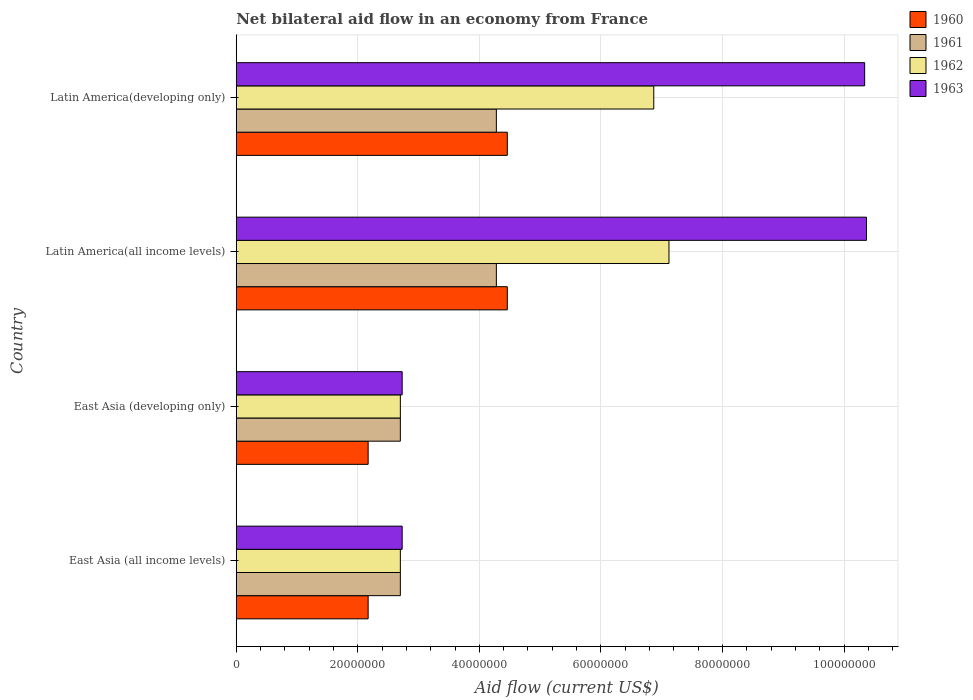How many different coloured bars are there?
Make the answer very short. 4. Are the number of bars per tick equal to the number of legend labels?
Offer a terse response. Yes. Are the number of bars on each tick of the Y-axis equal?
Your response must be concise. Yes. How many bars are there on the 1st tick from the top?
Ensure brevity in your answer.  4. How many bars are there on the 3rd tick from the bottom?
Provide a short and direct response. 4. What is the label of the 1st group of bars from the top?
Your response must be concise. Latin America(developing only). In how many cases, is the number of bars for a given country not equal to the number of legend labels?
Give a very brief answer. 0. What is the net bilateral aid flow in 1961 in East Asia (developing only)?
Offer a very short reply. 2.70e+07. Across all countries, what is the maximum net bilateral aid flow in 1960?
Keep it short and to the point. 4.46e+07. Across all countries, what is the minimum net bilateral aid flow in 1963?
Your answer should be compact. 2.73e+07. In which country was the net bilateral aid flow in 1962 maximum?
Give a very brief answer. Latin America(all income levels). In which country was the net bilateral aid flow in 1960 minimum?
Provide a short and direct response. East Asia (all income levels). What is the total net bilateral aid flow in 1963 in the graph?
Make the answer very short. 2.62e+08. What is the difference between the net bilateral aid flow in 1960 in Latin America(all income levels) and that in Latin America(developing only)?
Provide a succinct answer. 0. What is the difference between the net bilateral aid flow in 1963 in Latin America(developing only) and the net bilateral aid flow in 1962 in East Asia (all income levels)?
Your answer should be very brief. 7.64e+07. What is the average net bilateral aid flow in 1961 per country?
Give a very brief answer. 3.49e+07. What is the difference between the net bilateral aid flow in 1960 and net bilateral aid flow in 1963 in East Asia (developing only)?
Provide a succinct answer. -5.60e+06. What is the ratio of the net bilateral aid flow in 1961 in East Asia (all income levels) to that in Latin America(all income levels)?
Provide a short and direct response. 0.63. Is the net bilateral aid flow in 1962 in East Asia (developing only) less than that in Latin America(all income levels)?
Give a very brief answer. Yes. Is the difference between the net bilateral aid flow in 1960 in East Asia (all income levels) and Latin America(all income levels) greater than the difference between the net bilateral aid flow in 1963 in East Asia (all income levels) and Latin America(all income levels)?
Your answer should be very brief. Yes. What is the difference between the highest and the second highest net bilateral aid flow in 1963?
Your response must be concise. 3.00e+05. What is the difference between the highest and the lowest net bilateral aid flow in 1961?
Your answer should be compact. 1.58e+07. In how many countries, is the net bilateral aid flow in 1961 greater than the average net bilateral aid flow in 1961 taken over all countries?
Your answer should be compact. 2. Is it the case that in every country, the sum of the net bilateral aid flow in 1960 and net bilateral aid flow in 1961 is greater than the sum of net bilateral aid flow in 1963 and net bilateral aid flow in 1962?
Ensure brevity in your answer.  No. What does the 3rd bar from the top in Latin America(all income levels) represents?
Offer a terse response. 1961. Is it the case that in every country, the sum of the net bilateral aid flow in 1960 and net bilateral aid flow in 1961 is greater than the net bilateral aid flow in 1963?
Provide a succinct answer. No. Are all the bars in the graph horizontal?
Your response must be concise. Yes. How many countries are there in the graph?
Offer a terse response. 4. What is the difference between two consecutive major ticks on the X-axis?
Offer a terse response. 2.00e+07. Are the values on the major ticks of X-axis written in scientific E-notation?
Give a very brief answer. No. Does the graph contain any zero values?
Provide a short and direct response. No. How many legend labels are there?
Make the answer very short. 4. What is the title of the graph?
Keep it short and to the point. Net bilateral aid flow in an economy from France. Does "2003" appear as one of the legend labels in the graph?
Your response must be concise. No. What is the label or title of the X-axis?
Offer a terse response. Aid flow (current US$). What is the Aid flow (current US$) in 1960 in East Asia (all income levels)?
Make the answer very short. 2.17e+07. What is the Aid flow (current US$) of 1961 in East Asia (all income levels)?
Offer a terse response. 2.70e+07. What is the Aid flow (current US$) of 1962 in East Asia (all income levels)?
Offer a very short reply. 2.70e+07. What is the Aid flow (current US$) in 1963 in East Asia (all income levels)?
Your answer should be very brief. 2.73e+07. What is the Aid flow (current US$) in 1960 in East Asia (developing only)?
Offer a very short reply. 2.17e+07. What is the Aid flow (current US$) of 1961 in East Asia (developing only)?
Ensure brevity in your answer.  2.70e+07. What is the Aid flow (current US$) of 1962 in East Asia (developing only)?
Give a very brief answer. 2.70e+07. What is the Aid flow (current US$) in 1963 in East Asia (developing only)?
Provide a short and direct response. 2.73e+07. What is the Aid flow (current US$) of 1960 in Latin America(all income levels)?
Provide a succinct answer. 4.46e+07. What is the Aid flow (current US$) of 1961 in Latin America(all income levels)?
Give a very brief answer. 4.28e+07. What is the Aid flow (current US$) in 1962 in Latin America(all income levels)?
Offer a terse response. 7.12e+07. What is the Aid flow (current US$) of 1963 in Latin America(all income levels)?
Provide a short and direct response. 1.04e+08. What is the Aid flow (current US$) of 1960 in Latin America(developing only)?
Keep it short and to the point. 4.46e+07. What is the Aid flow (current US$) in 1961 in Latin America(developing only)?
Offer a terse response. 4.28e+07. What is the Aid flow (current US$) of 1962 in Latin America(developing only)?
Make the answer very short. 6.87e+07. What is the Aid flow (current US$) in 1963 in Latin America(developing only)?
Provide a succinct answer. 1.03e+08. Across all countries, what is the maximum Aid flow (current US$) in 1960?
Provide a succinct answer. 4.46e+07. Across all countries, what is the maximum Aid flow (current US$) of 1961?
Offer a terse response. 4.28e+07. Across all countries, what is the maximum Aid flow (current US$) of 1962?
Your answer should be compact. 7.12e+07. Across all countries, what is the maximum Aid flow (current US$) of 1963?
Offer a very short reply. 1.04e+08. Across all countries, what is the minimum Aid flow (current US$) of 1960?
Make the answer very short. 2.17e+07. Across all countries, what is the minimum Aid flow (current US$) in 1961?
Your answer should be compact. 2.70e+07. Across all countries, what is the minimum Aid flow (current US$) in 1962?
Your answer should be compact. 2.70e+07. Across all countries, what is the minimum Aid flow (current US$) of 1963?
Give a very brief answer. 2.73e+07. What is the total Aid flow (current US$) of 1960 in the graph?
Your answer should be compact. 1.33e+08. What is the total Aid flow (current US$) in 1961 in the graph?
Offer a terse response. 1.40e+08. What is the total Aid flow (current US$) of 1962 in the graph?
Provide a succinct answer. 1.94e+08. What is the total Aid flow (current US$) in 1963 in the graph?
Provide a succinct answer. 2.62e+08. What is the difference between the Aid flow (current US$) in 1961 in East Asia (all income levels) and that in East Asia (developing only)?
Provide a succinct answer. 0. What is the difference between the Aid flow (current US$) of 1960 in East Asia (all income levels) and that in Latin America(all income levels)?
Your response must be concise. -2.29e+07. What is the difference between the Aid flow (current US$) of 1961 in East Asia (all income levels) and that in Latin America(all income levels)?
Your answer should be compact. -1.58e+07. What is the difference between the Aid flow (current US$) in 1962 in East Asia (all income levels) and that in Latin America(all income levels)?
Provide a succinct answer. -4.42e+07. What is the difference between the Aid flow (current US$) of 1963 in East Asia (all income levels) and that in Latin America(all income levels)?
Your answer should be very brief. -7.64e+07. What is the difference between the Aid flow (current US$) in 1960 in East Asia (all income levels) and that in Latin America(developing only)?
Provide a succinct answer. -2.29e+07. What is the difference between the Aid flow (current US$) of 1961 in East Asia (all income levels) and that in Latin America(developing only)?
Make the answer very short. -1.58e+07. What is the difference between the Aid flow (current US$) of 1962 in East Asia (all income levels) and that in Latin America(developing only)?
Your answer should be very brief. -4.17e+07. What is the difference between the Aid flow (current US$) of 1963 in East Asia (all income levels) and that in Latin America(developing only)?
Keep it short and to the point. -7.61e+07. What is the difference between the Aid flow (current US$) of 1960 in East Asia (developing only) and that in Latin America(all income levels)?
Provide a short and direct response. -2.29e+07. What is the difference between the Aid flow (current US$) of 1961 in East Asia (developing only) and that in Latin America(all income levels)?
Offer a terse response. -1.58e+07. What is the difference between the Aid flow (current US$) in 1962 in East Asia (developing only) and that in Latin America(all income levels)?
Offer a very short reply. -4.42e+07. What is the difference between the Aid flow (current US$) of 1963 in East Asia (developing only) and that in Latin America(all income levels)?
Your answer should be very brief. -7.64e+07. What is the difference between the Aid flow (current US$) in 1960 in East Asia (developing only) and that in Latin America(developing only)?
Offer a terse response. -2.29e+07. What is the difference between the Aid flow (current US$) of 1961 in East Asia (developing only) and that in Latin America(developing only)?
Provide a succinct answer. -1.58e+07. What is the difference between the Aid flow (current US$) of 1962 in East Asia (developing only) and that in Latin America(developing only)?
Ensure brevity in your answer.  -4.17e+07. What is the difference between the Aid flow (current US$) in 1963 in East Asia (developing only) and that in Latin America(developing only)?
Your response must be concise. -7.61e+07. What is the difference between the Aid flow (current US$) of 1961 in Latin America(all income levels) and that in Latin America(developing only)?
Offer a very short reply. 0. What is the difference between the Aid flow (current US$) in 1962 in Latin America(all income levels) and that in Latin America(developing only)?
Provide a short and direct response. 2.50e+06. What is the difference between the Aid flow (current US$) of 1960 in East Asia (all income levels) and the Aid flow (current US$) of 1961 in East Asia (developing only)?
Make the answer very short. -5.30e+06. What is the difference between the Aid flow (current US$) of 1960 in East Asia (all income levels) and the Aid flow (current US$) of 1962 in East Asia (developing only)?
Provide a succinct answer. -5.30e+06. What is the difference between the Aid flow (current US$) of 1960 in East Asia (all income levels) and the Aid flow (current US$) of 1963 in East Asia (developing only)?
Make the answer very short. -5.60e+06. What is the difference between the Aid flow (current US$) in 1961 in East Asia (all income levels) and the Aid flow (current US$) in 1962 in East Asia (developing only)?
Make the answer very short. 0. What is the difference between the Aid flow (current US$) in 1960 in East Asia (all income levels) and the Aid flow (current US$) in 1961 in Latin America(all income levels)?
Offer a terse response. -2.11e+07. What is the difference between the Aid flow (current US$) of 1960 in East Asia (all income levels) and the Aid flow (current US$) of 1962 in Latin America(all income levels)?
Give a very brief answer. -4.95e+07. What is the difference between the Aid flow (current US$) in 1960 in East Asia (all income levels) and the Aid flow (current US$) in 1963 in Latin America(all income levels)?
Provide a succinct answer. -8.20e+07. What is the difference between the Aid flow (current US$) of 1961 in East Asia (all income levels) and the Aid flow (current US$) of 1962 in Latin America(all income levels)?
Provide a short and direct response. -4.42e+07. What is the difference between the Aid flow (current US$) in 1961 in East Asia (all income levels) and the Aid flow (current US$) in 1963 in Latin America(all income levels)?
Your answer should be very brief. -7.67e+07. What is the difference between the Aid flow (current US$) of 1962 in East Asia (all income levels) and the Aid flow (current US$) of 1963 in Latin America(all income levels)?
Make the answer very short. -7.67e+07. What is the difference between the Aid flow (current US$) in 1960 in East Asia (all income levels) and the Aid flow (current US$) in 1961 in Latin America(developing only)?
Keep it short and to the point. -2.11e+07. What is the difference between the Aid flow (current US$) in 1960 in East Asia (all income levels) and the Aid flow (current US$) in 1962 in Latin America(developing only)?
Your answer should be compact. -4.70e+07. What is the difference between the Aid flow (current US$) of 1960 in East Asia (all income levels) and the Aid flow (current US$) of 1963 in Latin America(developing only)?
Provide a succinct answer. -8.17e+07. What is the difference between the Aid flow (current US$) of 1961 in East Asia (all income levels) and the Aid flow (current US$) of 1962 in Latin America(developing only)?
Your response must be concise. -4.17e+07. What is the difference between the Aid flow (current US$) in 1961 in East Asia (all income levels) and the Aid flow (current US$) in 1963 in Latin America(developing only)?
Provide a short and direct response. -7.64e+07. What is the difference between the Aid flow (current US$) of 1962 in East Asia (all income levels) and the Aid flow (current US$) of 1963 in Latin America(developing only)?
Provide a short and direct response. -7.64e+07. What is the difference between the Aid flow (current US$) in 1960 in East Asia (developing only) and the Aid flow (current US$) in 1961 in Latin America(all income levels)?
Make the answer very short. -2.11e+07. What is the difference between the Aid flow (current US$) of 1960 in East Asia (developing only) and the Aid flow (current US$) of 1962 in Latin America(all income levels)?
Provide a short and direct response. -4.95e+07. What is the difference between the Aid flow (current US$) of 1960 in East Asia (developing only) and the Aid flow (current US$) of 1963 in Latin America(all income levels)?
Your response must be concise. -8.20e+07. What is the difference between the Aid flow (current US$) in 1961 in East Asia (developing only) and the Aid flow (current US$) in 1962 in Latin America(all income levels)?
Provide a succinct answer. -4.42e+07. What is the difference between the Aid flow (current US$) of 1961 in East Asia (developing only) and the Aid flow (current US$) of 1963 in Latin America(all income levels)?
Your answer should be compact. -7.67e+07. What is the difference between the Aid flow (current US$) of 1962 in East Asia (developing only) and the Aid flow (current US$) of 1963 in Latin America(all income levels)?
Offer a terse response. -7.67e+07. What is the difference between the Aid flow (current US$) of 1960 in East Asia (developing only) and the Aid flow (current US$) of 1961 in Latin America(developing only)?
Offer a very short reply. -2.11e+07. What is the difference between the Aid flow (current US$) of 1960 in East Asia (developing only) and the Aid flow (current US$) of 1962 in Latin America(developing only)?
Offer a very short reply. -4.70e+07. What is the difference between the Aid flow (current US$) of 1960 in East Asia (developing only) and the Aid flow (current US$) of 1963 in Latin America(developing only)?
Make the answer very short. -8.17e+07. What is the difference between the Aid flow (current US$) of 1961 in East Asia (developing only) and the Aid flow (current US$) of 1962 in Latin America(developing only)?
Offer a very short reply. -4.17e+07. What is the difference between the Aid flow (current US$) in 1961 in East Asia (developing only) and the Aid flow (current US$) in 1963 in Latin America(developing only)?
Give a very brief answer. -7.64e+07. What is the difference between the Aid flow (current US$) of 1962 in East Asia (developing only) and the Aid flow (current US$) of 1963 in Latin America(developing only)?
Keep it short and to the point. -7.64e+07. What is the difference between the Aid flow (current US$) in 1960 in Latin America(all income levels) and the Aid flow (current US$) in 1961 in Latin America(developing only)?
Make the answer very short. 1.80e+06. What is the difference between the Aid flow (current US$) of 1960 in Latin America(all income levels) and the Aid flow (current US$) of 1962 in Latin America(developing only)?
Provide a succinct answer. -2.41e+07. What is the difference between the Aid flow (current US$) in 1960 in Latin America(all income levels) and the Aid flow (current US$) in 1963 in Latin America(developing only)?
Offer a terse response. -5.88e+07. What is the difference between the Aid flow (current US$) in 1961 in Latin America(all income levels) and the Aid flow (current US$) in 1962 in Latin America(developing only)?
Provide a succinct answer. -2.59e+07. What is the difference between the Aid flow (current US$) of 1961 in Latin America(all income levels) and the Aid flow (current US$) of 1963 in Latin America(developing only)?
Give a very brief answer. -6.06e+07. What is the difference between the Aid flow (current US$) in 1962 in Latin America(all income levels) and the Aid flow (current US$) in 1963 in Latin America(developing only)?
Give a very brief answer. -3.22e+07. What is the average Aid flow (current US$) of 1960 per country?
Your answer should be very brief. 3.32e+07. What is the average Aid flow (current US$) in 1961 per country?
Offer a terse response. 3.49e+07. What is the average Aid flow (current US$) of 1962 per country?
Make the answer very short. 4.85e+07. What is the average Aid flow (current US$) of 1963 per country?
Your response must be concise. 6.54e+07. What is the difference between the Aid flow (current US$) of 1960 and Aid flow (current US$) of 1961 in East Asia (all income levels)?
Your answer should be very brief. -5.30e+06. What is the difference between the Aid flow (current US$) of 1960 and Aid flow (current US$) of 1962 in East Asia (all income levels)?
Make the answer very short. -5.30e+06. What is the difference between the Aid flow (current US$) of 1960 and Aid flow (current US$) of 1963 in East Asia (all income levels)?
Your response must be concise. -5.60e+06. What is the difference between the Aid flow (current US$) of 1962 and Aid flow (current US$) of 1963 in East Asia (all income levels)?
Make the answer very short. -3.00e+05. What is the difference between the Aid flow (current US$) of 1960 and Aid flow (current US$) of 1961 in East Asia (developing only)?
Make the answer very short. -5.30e+06. What is the difference between the Aid flow (current US$) of 1960 and Aid flow (current US$) of 1962 in East Asia (developing only)?
Your answer should be compact. -5.30e+06. What is the difference between the Aid flow (current US$) in 1960 and Aid flow (current US$) in 1963 in East Asia (developing only)?
Keep it short and to the point. -5.60e+06. What is the difference between the Aid flow (current US$) in 1960 and Aid flow (current US$) in 1961 in Latin America(all income levels)?
Provide a succinct answer. 1.80e+06. What is the difference between the Aid flow (current US$) of 1960 and Aid flow (current US$) of 1962 in Latin America(all income levels)?
Keep it short and to the point. -2.66e+07. What is the difference between the Aid flow (current US$) of 1960 and Aid flow (current US$) of 1963 in Latin America(all income levels)?
Ensure brevity in your answer.  -5.91e+07. What is the difference between the Aid flow (current US$) of 1961 and Aid flow (current US$) of 1962 in Latin America(all income levels)?
Your response must be concise. -2.84e+07. What is the difference between the Aid flow (current US$) in 1961 and Aid flow (current US$) in 1963 in Latin America(all income levels)?
Provide a succinct answer. -6.09e+07. What is the difference between the Aid flow (current US$) in 1962 and Aid flow (current US$) in 1963 in Latin America(all income levels)?
Provide a succinct answer. -3.25e+07. What is the difference between the Aid flow (current US$) of 1960 and Aid flow (current US$) of 1961 in Latin America(developing only)?
Provide a short and direct response. 1.80e+06. What is the difference between the Aid flow (current US$) of 1960 and Aid flow (current US$) of 1962 in Latin America(developing only)?
Give a very brief answer. -2.41e+07. What is the difference between the Aid flow (current US$) in 1960 and Aid flow (current US$) in 1963 in Latin America(developing only)?
Ensure brevity in your answer.  -5.88e+07. What is the difference between the Aid flow (current US$) of 1961 and Aid flow (current US$) of 1962 in Latin America(developing only)?
Give a very brief answer. -2.59e+07. What is the difference between the Aid flow (current US$) of 1961 and Aid flow (current US$) of 1963 in Latin America(developing only)?
Provide a short and direct response. -6.06e+07. What is the difference between the Aid flow (current US$) of 1962 and Aid flow (current US$) of 1963 in Latin America(developing only)?
Ensure brevity in your answer.  -3.47e+07. What is the ratio of the Aid flow (current US$) in 1961 in East Asia (all income levels) to that in East Asia (developing only)?
Offer a terse response. 1. What is the ratio of the Aid flow (current US$) in 1963 in East Asia (all income levels) to that in East Asia (developing only)?
Your answer should be compact. 1. What is the ratio of the Aid flow (current US$) in 1960 in East Asia (all income levels) to that in Latin America(all income levels)?
Your answer should be compact. 0.49. What is the ratio of the Aid flow (current US$) of 1961 in East Asia (all income levels) to that in Latin America(all income levels)?
Offer a very short reply. 0.63. What is the ratio of the Aid flow (current US$) of 1962 in East Asia (all income levels) to that in Latin America(all income levels)?
Provide a succinct answer. 0.38. What is the ratio of the Aid flow (current US$) of 1963 in East Asia (all income levels) to that in Latin America(all income levels)?
Offer a terse response. 0.26. What is the ratio of the Aid flow (current US$) of 1960 in East Asia (all income levels) to that in Latin America(developing only)?
Provide a short and direct response. 0.49. What is the ratio of the Aid flow (current US$) in 1961 in East Asia (all income levels) to that in Latin America(developing only)?
Offer a terse response. 0.63. What is the ratio of the Aid flow (current US$) of 1962 in East Asia (all income levels) to that in Latin America(developing only)?
Ensure brevity in your answer.  0.39. What is the ratio of the Aid flow (current US$) in 1963 in East Asia (all income levels) to that in Latin America(developing only)?
Your answer should be very brief. 0.26. What is the ratio of the Aid flow (current US$) of 1960 in East Asia (developing only) to that in Latin America(all income levels)?
Offer a terse response. 0.49. What is the ratio of the Aid flow (current US$) of 1961 in East Asia (developing only) to that in Latin America(all income levels)?
Ensure brevity in your answer.  0.63. What is the ratio of the Aid flow (current US$) in 1962 in East Asia (developing only) to that in Latin America(all income levels)?
Give a very brief answer. 0.38. What is the ratio of the Aid flow (current US$) in 1963 in East Asia (developing only) to that in Latin America(all income levels)?
Ensure brevity in your answer.  0.26. What is the ratio of the Aid flow (current US$) of 1960 in East Asia (developing only) to that in Latin America(developing only)?
Keep it short and to the point. 0.49. What is the ratio of the Aid flow (current US$) of 1961 in East Asia (developing only) to that in Latin America(developing only)?
Keep it short and to the point. 0.63. What is the ratio of the Aid flow (current US$) of 1962 in East Asia (developing only) to that in Latin America(developing only)?
Your response must be concise. 0.39. What is the ratio of the Aid flow (current US$) in 1963 in East Asia (developing only) to that in Latin America(developing only)?
Give a very brief answer. 0.26. What is the ratio of the Aid flow (current US$) in 1962 in Latin America(all income levels) to that in Latin America(developing only)?
Your answer should be compact. 1.04. What is the ratio of the Aid flow (current US$) of 1963 in Latin America(all income levels) to that in Latin America(developing only)?
Provide a short and direct response. 1. What is the difference between the highest and the second highest Aid flow (current US$) in 1960?
Provide a short and direct response. 0. What is the difference between the highest and the second highest Aid flow (current US$) of 1962?
Offer a terse response. 2.50e+06. What is the difference between the highest and the second highest Aid flow (current US$) of 1963?
Offer a terse response. 3.00e+05. What is the difference between the highest and the lowest Aid flow (current US$) in 1960?
Give a very brief answer. 2.29e+07. What is the difference between the highest and the lowest Aid flow (current US$) of 1961?
Your answer should be very brief. 1.58e+07. What is the difference between the highest and the lowest Aid flow (current US$) in 1962?
Your response must be concise. 4.42e+07. What is the difference between the highest and the lowest Aid flow (current US$) of 1963?
Your answer should be compact. 7.64e+07. 